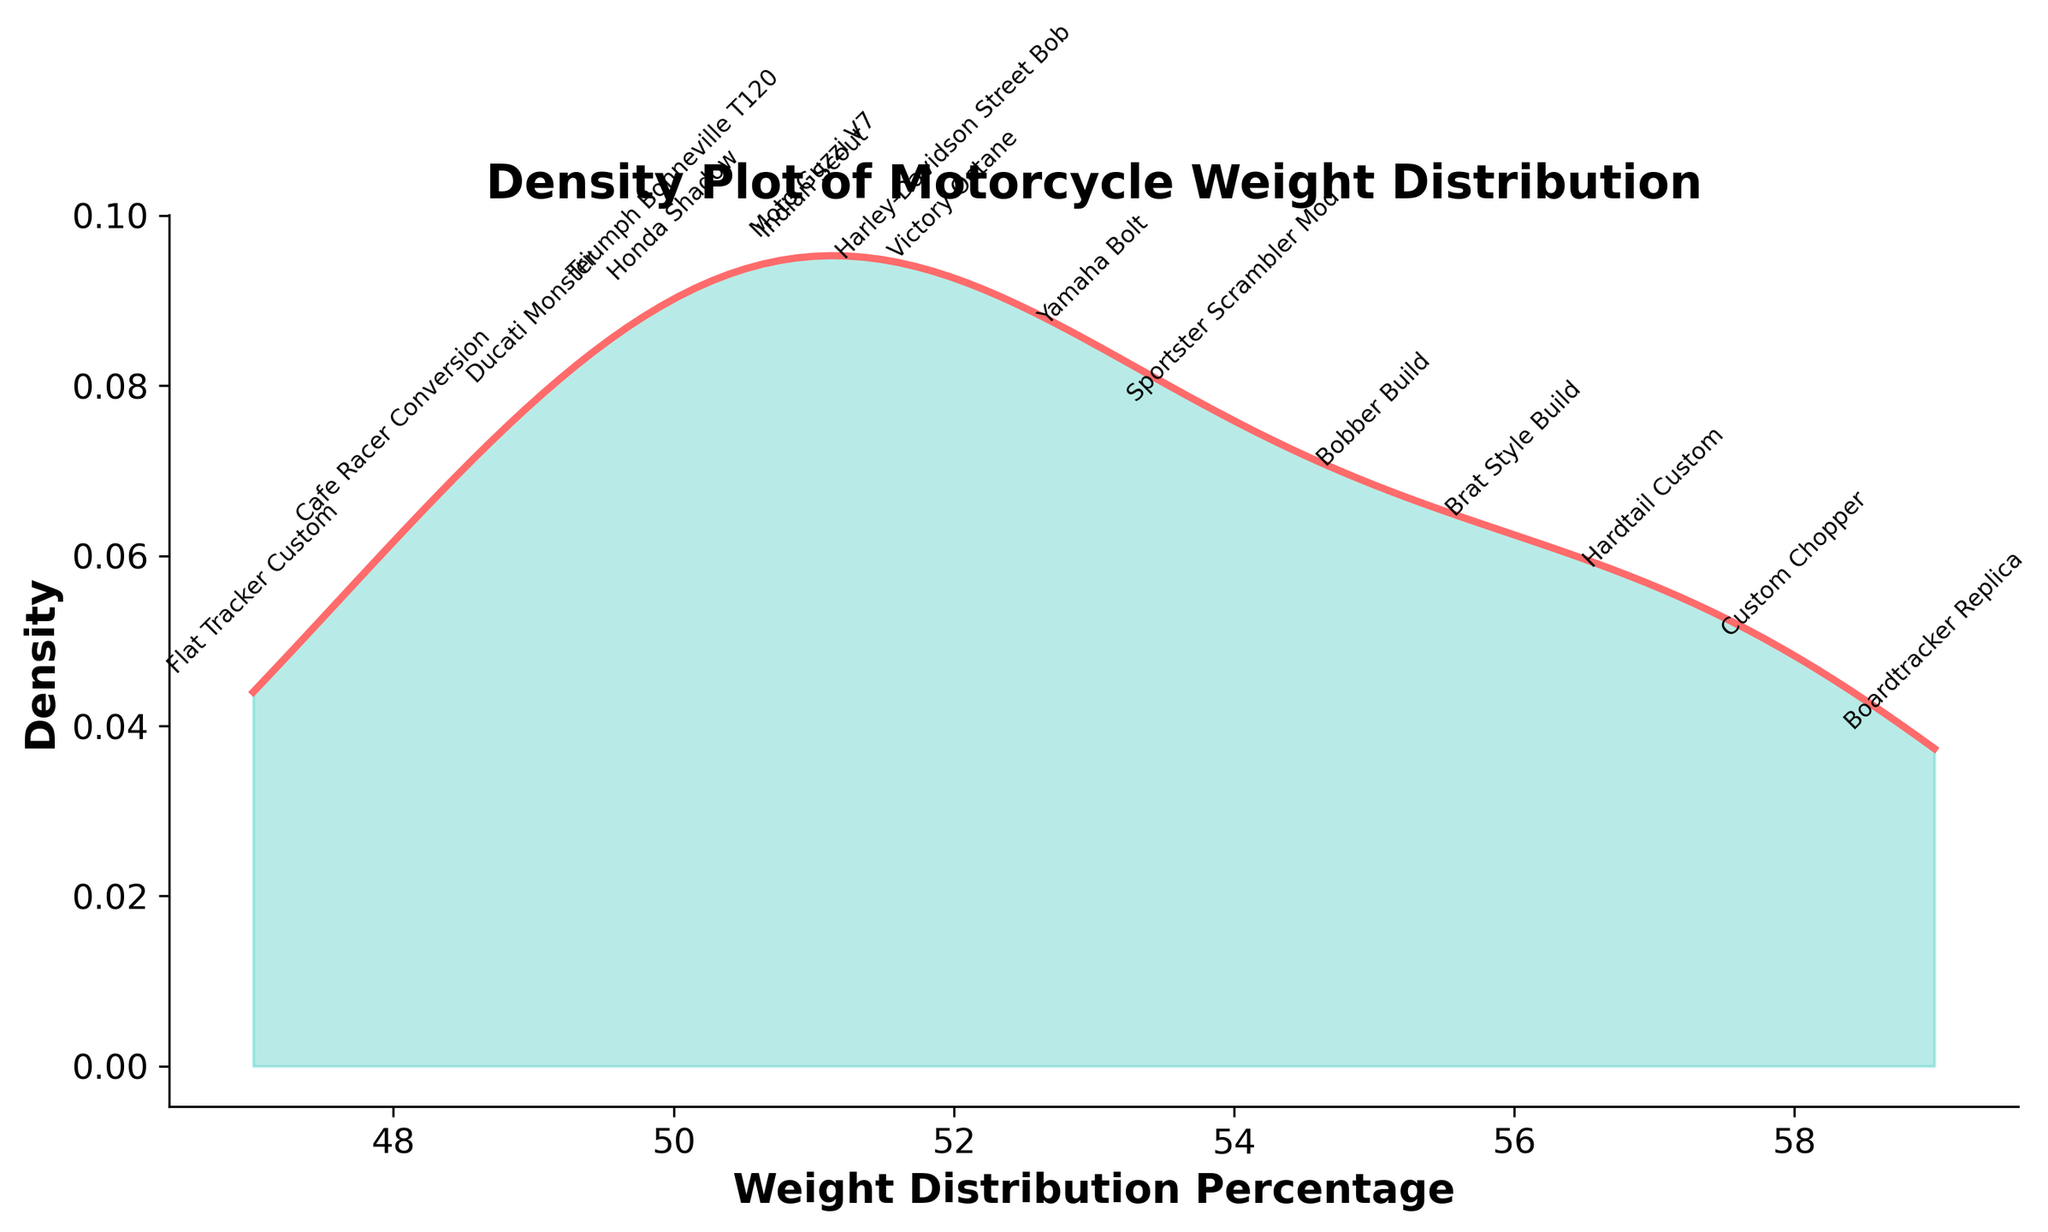What is the title of the plot? The title is usually displayed at the top of the figure. In this case, it states, "Density Plot of Motorcycle Weight Distribution."
Answer: Density Plot of Motorcycle Weight Distribution How many motorcycle types are annotated on the figure? Each annotation corresponds to a data point. By counting the labels, we see there are 16 motorcycle types.
Answer: 16 Which motorcycle type has the lowest weight distribution percentage? By looking at the annotated data points and their corresponding values, the "Flat Tracker Custom" shows the lowest weight distribution at 47%.
Answer: Flat Tracker Custom What is the range of the weight distribution percentages plotted? The range can be determined by identifying the minimum and maximum percentages displayed in the plot. The minimum is 47% and the maximum is 59%.
Answer: 47% to 59% Which motorcycle has a weight distribution percentage closest to the central peak of the density plot? Observing the central peak of the density plot and looking for the closest annotated motorcycle type, the "Harley-Davidson Street Bob" at 52% is nearest to the central peak.
Answer: Harley-Davidson Street Bob Compare the weight distribution percentages of the "Cafe Racer Conversion" and the "Bobber Build". Which has a higher percentage and by how much? The "Cafe Racer Conversion" has a weight percentage of 48% and the "Bobber Build" has 55%. The difference is 55% - 48% = 7%.
Answer: Bobber Build by 7% Is the weight distribution of custom-built motorcycles generally higher or lower compared to factory models based on the plot? By reviewing the individual labels, custom-built motorcycles like "Custom Chopper", "Bobber Build", and "Hardtail Custom" have relatively higher percentages compared to many factory models like "Triumph Bonneville T120" and "Honda Shadow". Thus, custom-built motorcycles tend to have a higher weight distribution.
Answer: Generally higher Which has a higher density peak, weight distributions at around 50% or 55%? By looking at the height of the KDE curve, it is evident that the area around 55% has a higher density peak than the area around 50%.
Answer: Around 55% What does the filled area under the density curve represent in the context of this plot? The filled area under the KDE curve represents the distribution of density across different weight percentages, indicating the probability of weight distribution percentages among the motorcycles.
Answer: Distribution of density Are there more customized bikes above or below the 50% weight distribution mark in general according to the plot? Observing the annotations above and below the 50% mark shows that more custom motorcycles have higher percentage distributions (e.g., Custom Chopper, Bobber Build) compared to those below 50% like Cafe Racer Conversion and Flat Tracker Custom.
Answer: Above 